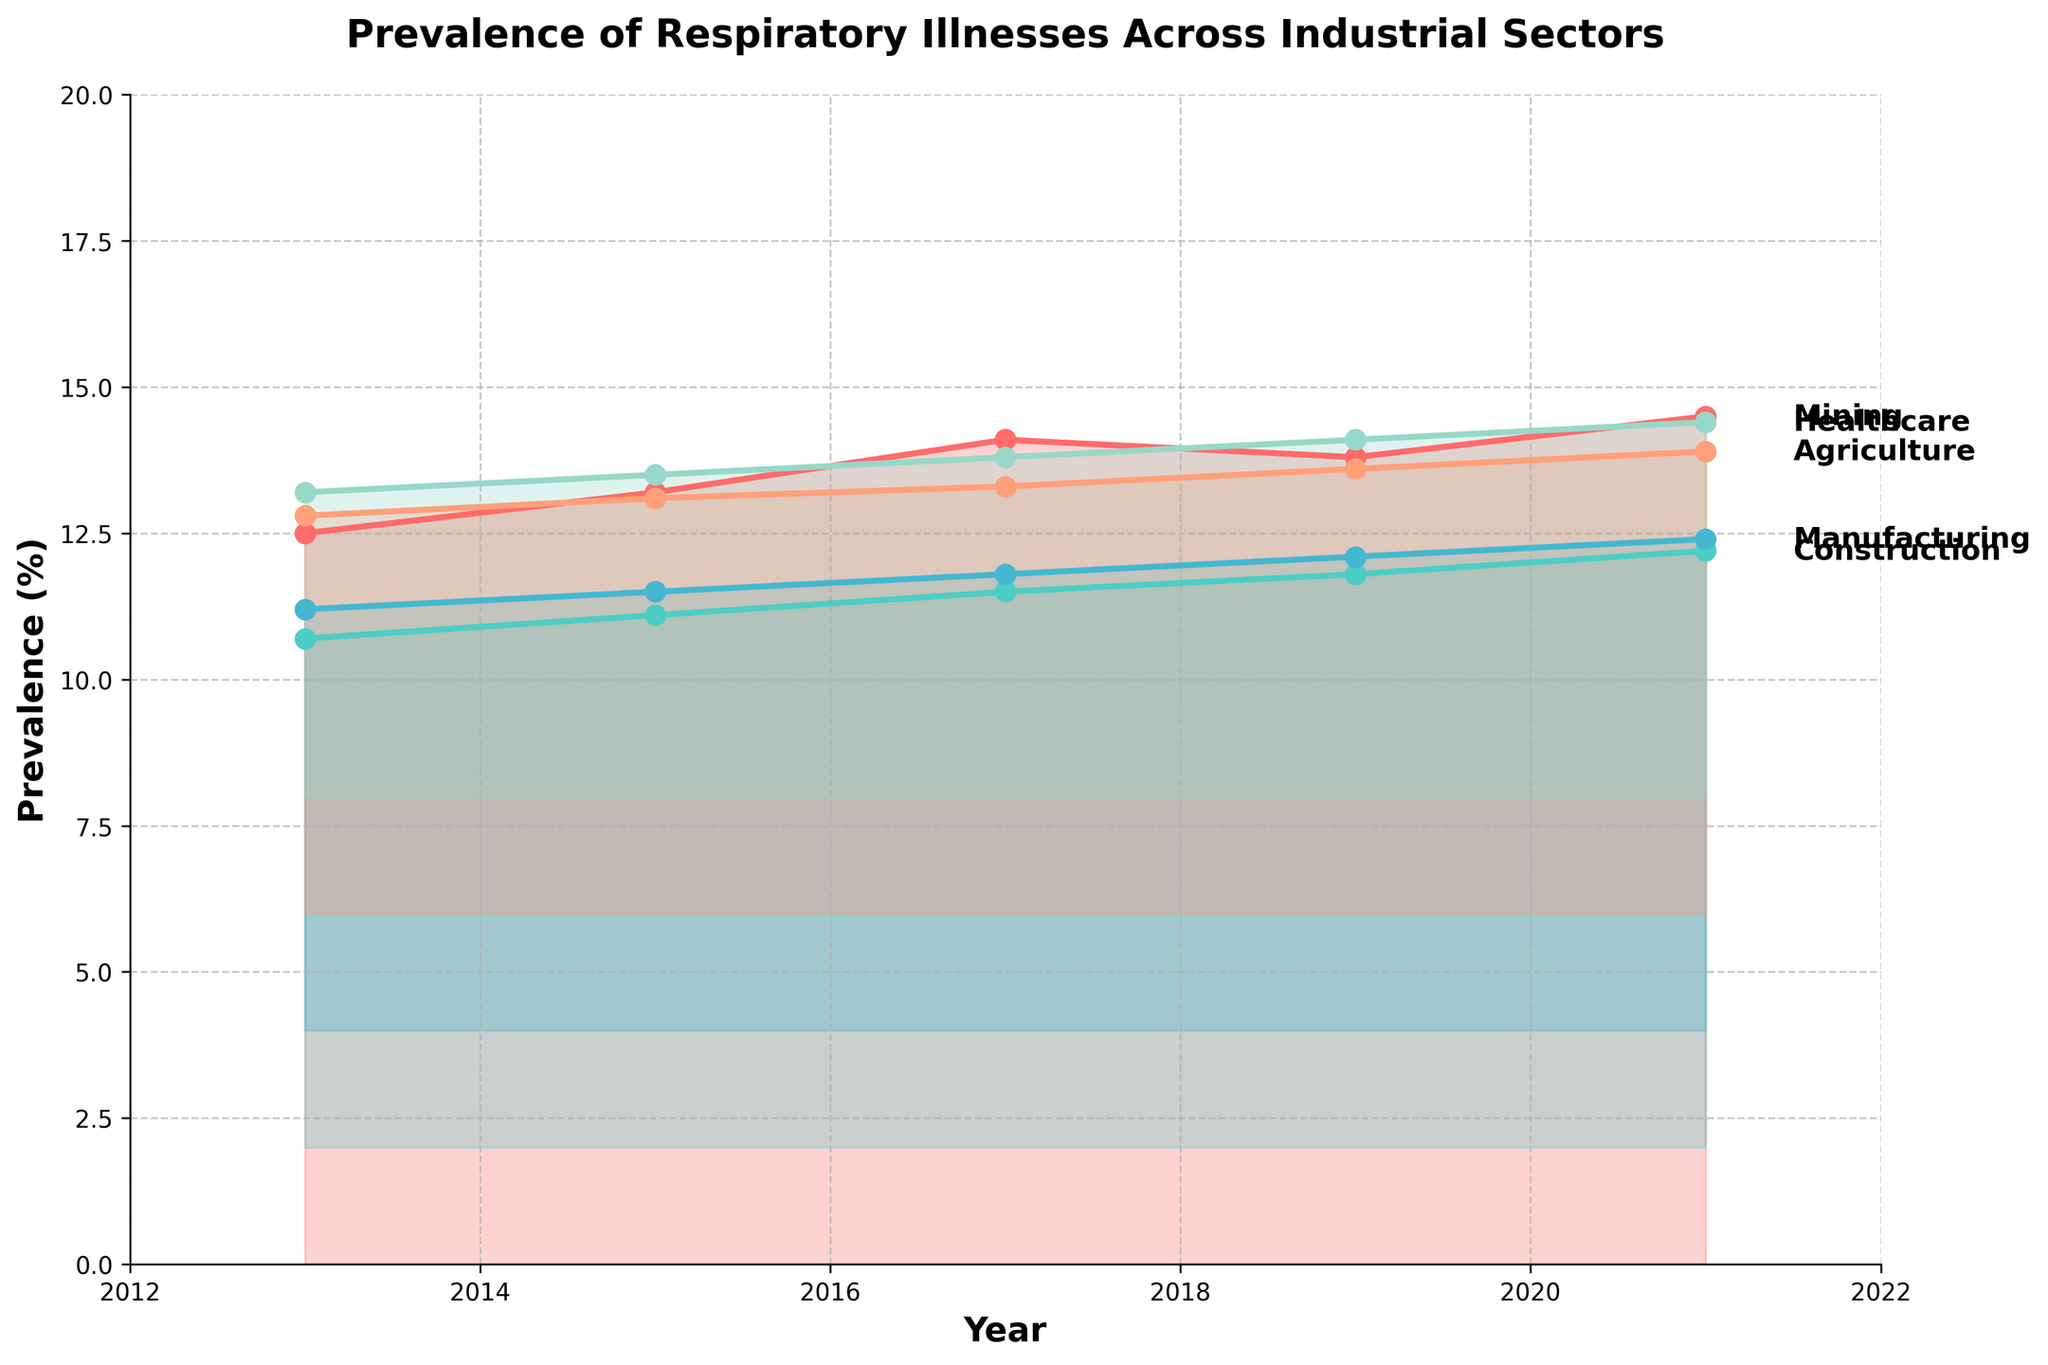What is the title of the plot? The title is displayed at the top of the plot.
Answer: Prevalence of Respiratory Illnesses Across Industrial Sectors How many industrial sectors are analyzed in the plot? To determine this, count the unique labels on the right side of the plot where each industry's name is shown.
Answer: 5 Which industry shows the highest prevalence of respiratory illnesses in 2021? Look at the data points corresponding to the year 2021 and identify which industry has the highest value.
Answer: Mining What's the difference in respiratory illness prevalence between Healthcare and Agriculture sectors in 2021? Find the prevalence values for Healthcare and Agriculture in 2021, then subtract the Healthcare value from the Agriculture value.
Answer: 1.5 How has the prevalence of respiratory illnesses in the Manufacturing sector changed from 2013 to 2021? Identify the data points for Manufacturing in 2013 and 2021 and calculate the difference.
Answer: Increased by 1.2 Which industry had the lowest initial prevalence in 2013? Compare the prevalence values for each industry in the year 2013 and determine the smallest one.
Answer: Healthcare Which industry has shown the most consistent increase in prevalence over the years? Check the trends of each industry; consistent increase means not having a year where the value decreases.
Answer: Construction What is the average prevalence of respiratory illnesses in the Construction sector over the 5 data points? Sum the prevalence values for Construction and divide by the number of data points.
Answer: 9.46 Between 2013 and 2017, which industry experienced the largest increase in prevalence? Compare the difference in prevalence between 2013 and 2017 for each industry and identify the largest change.
Answer: Mining What pattern do you observe about the prevalence trends across all industrial sectors? Observe the overall trend from 2013 to 2021 for each sector and see if there are any common movements.
Answer: All sectors show an increasing trend 